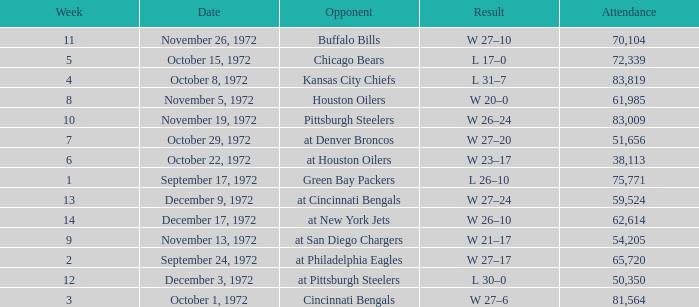What is the sum of week number(s) had an attendance of 61,985? 1.0. 